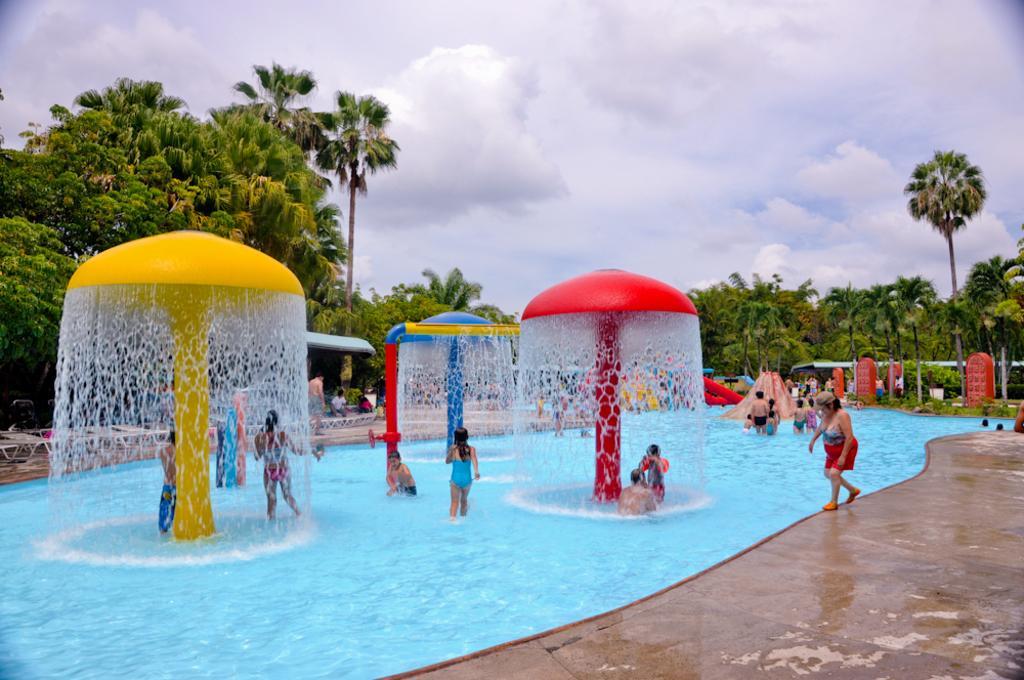Can you describe this image briefly? In this picture, we see people are in the water and this water is in the swimming pool. Here, we see some things which look like the umbrellas and water is falling through those umbrellas. These are in yellow, red and blue color. On the right side, we see red color objects, trees and a shed. There are trees in the background. At the top, we see the sky. This picture is clicked in the park. 